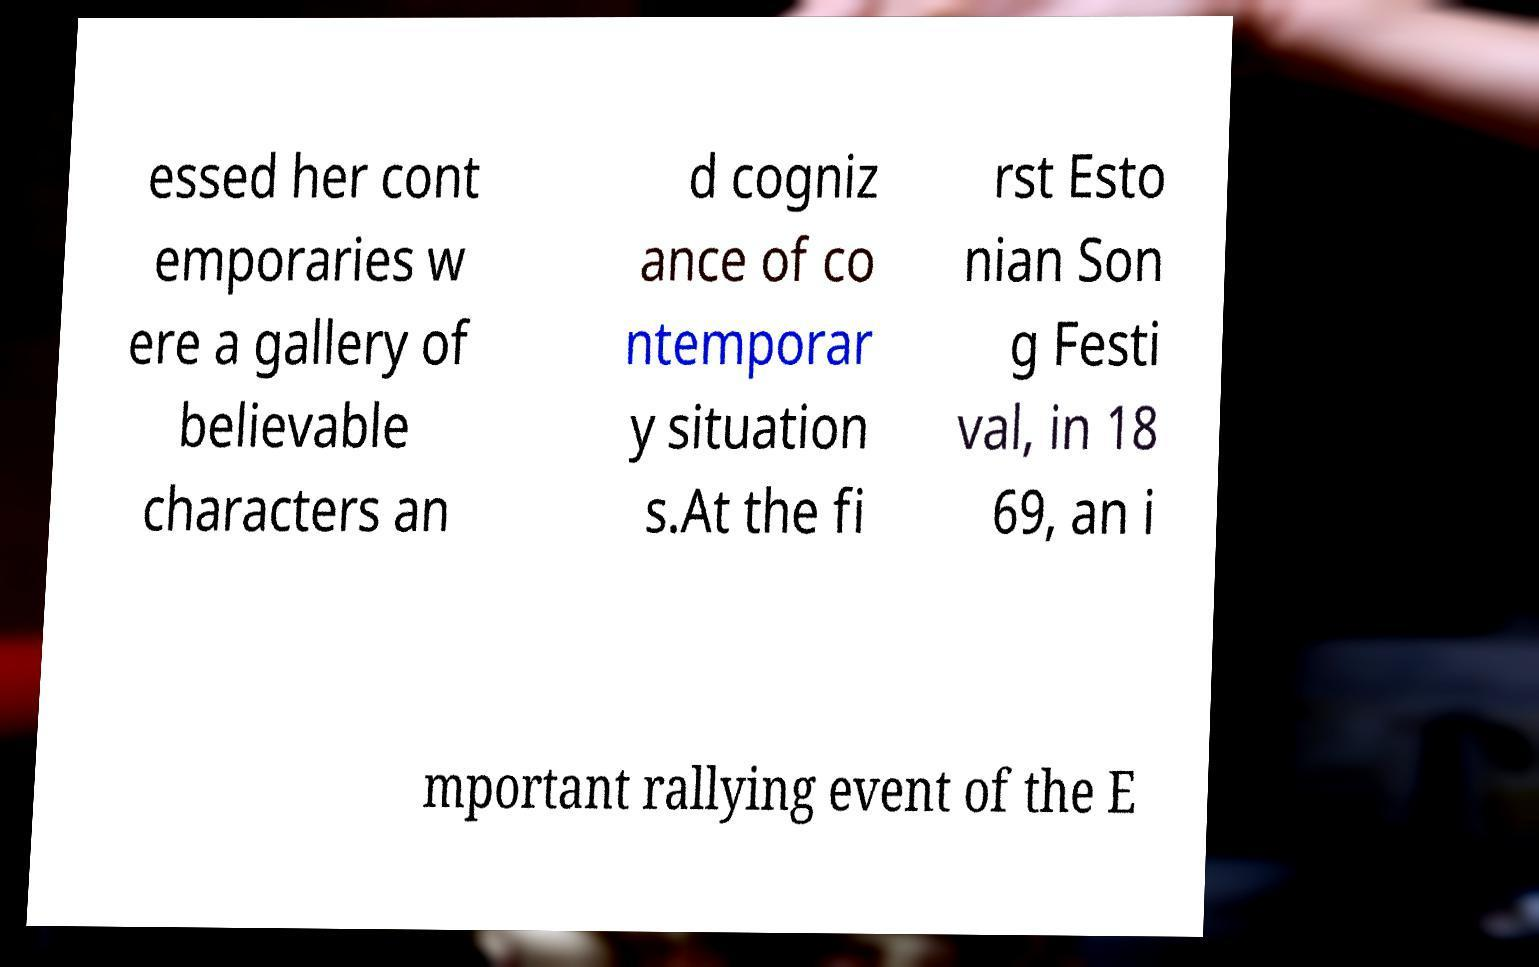Please read and relay the text visible in this image. What does it say? essed her cont emporaries w ere a gallery of believable characters an d cogniz ance of co ntemporar y situation s.At the fi rst Esto nian Son g Festi val, in 18 69, an i mportant rallying event of the E 